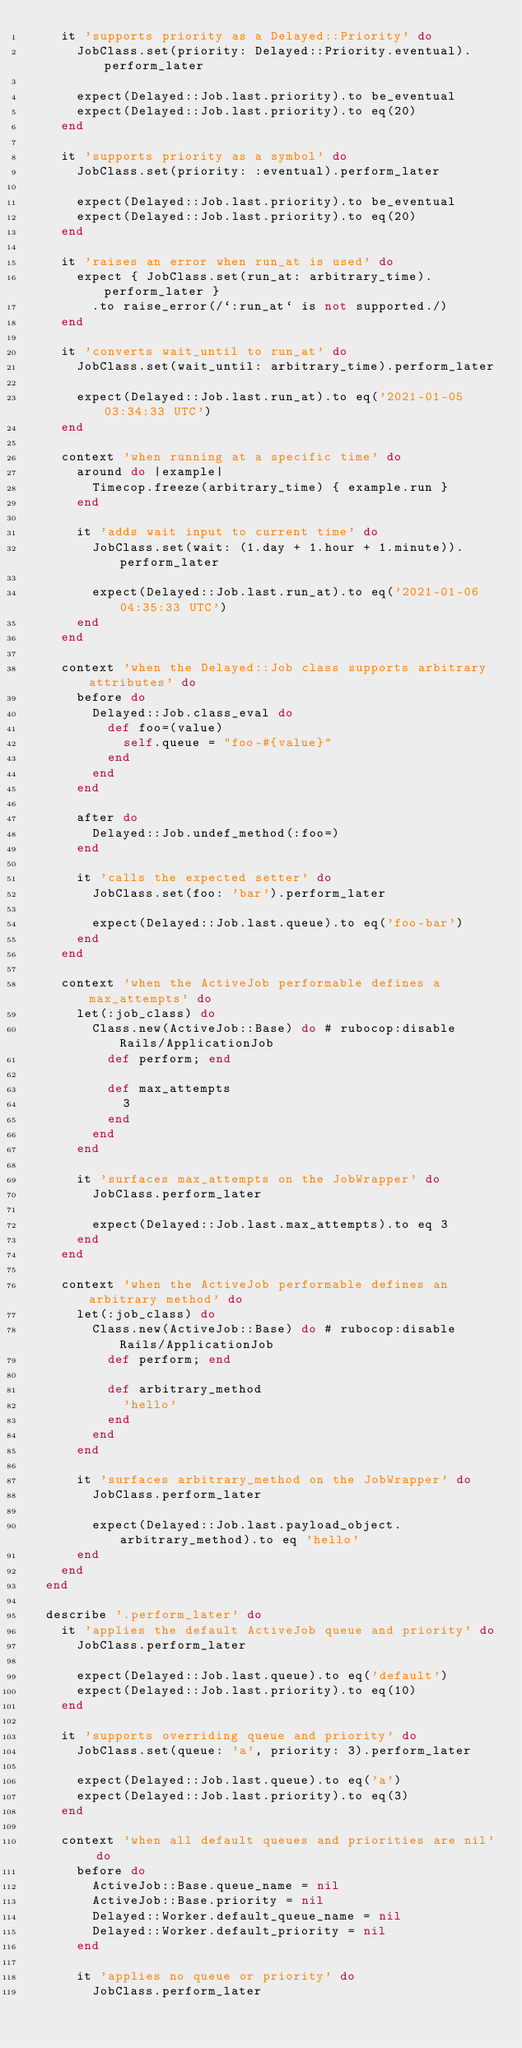<code> <loc_0><loc_0><loc_500><loc_500><_Ruby_>    it 'supports priority as a Delayed::Priority' do
      JobClass.set(priority: Delayed::Priority.eventual).perform_later

      expect(Delayed::Job.last.priority).to be_eventual
      expect(Delayed::Job.last.priority).to eq(20)
    end

    it 'supports priority as a symbol' do
      JobClass.set(priority: :eventual).perform_later

      expect(Delayed::Job.last.priority).to be_eventual
      expect(Delayed::Job.last.priority).to eq(20)
    end

    it 'raises an error when run_at is used' do
      expect { JobClass.set(run_at: arbitrary_time).perform_later }
        .to raise_error(/`:run_at` is not supported./)
    end

    it 'converts wait_until to run_at' do
      JobClass.set(wait_until: arbitrary_time).perform_later

      expect(Delayed::Job.last.run_at).to eq('2021-01-05 03:34:33 UTC')
    end

    context 'when running at a specific time' do
      around do |example|
        Timecop.freeze(arbitrary_time) { example.run }
      end

      it 'adds wait input to current time' do
        JobClass.set(wait: (1.day + 1.hour + 1.minute)).perform_later

        expect(Delayed::Job.last.run_at).to eq('2021-01-06 04:35:33 UTC')
      end
    end

    context 'when the Delayed::Job class supports arbitrary attributes' do
      before do
        Delayed::Job.class_eval do
          def foo=(value)
            self.queue = "foo-#{value}"
          end
        end
      end

      after do
        Delayed::Job.undef_method(:foo=)
      end

      it 'calls the expected setter' do
        JobClass.set(foo: 'bar').perform_later

        expect(Delayed::Job.last.queue).to eq('foo-bar')
      end
    end

    context 'when the ActiveJob performable defines a max_attempts' do
      let(:job_class) do
        Class.new(ActiveJob::Base) do # rubocop:disable Rails/ApplicationJob
          def perform; end

          def max_attempts
            3
          end
        end
      end

      it 'surfaces max_attempts on the JobWrapper' do
        JobClass.perform_later

        expect(Delayed::Job.last.max_attempts).to eq 3
      end
    end

    context 'when the ActiveJob performable defines an arbitrary method' do
      let(:job_class) do
        Class.new(ActiveJob::Base) do # rubocop:disable Rails/ApplicationJob
          def perform; end

          def arbitrary_method
            'hello'
          end
        end
      end

      it 'surfaces arbitrary_method on the JobWrapper' do
        JobClass.perform_later

        expect(Delayed::Job.last.payload_object.arbitrary_method).to eq 'hello'
      end
    end
  end

  describe '.perform_later' do
    it 'applies the default ActiveJob queue and priority' do
      JobClass.perform_later

      expect(Delayed::Job.last.queue).to eq('default')
      expect(Delayed::Job.last.priority).to eq(10)
    end

    it 'supports overriding queue and priority' do
      JobClass.set(queue: 'a', priority: 3).perform_later

      expect(Delayed::Job.last.queue).to eq('a')
      expect(Delayed::Job.last.priority).to eq(3)
    end

    context 'when all default queues and priorities are nil' do
      before do
        ActiveJob::Base.queue_name = nil
        ActiveJob::Base.priority = nil
        Delayed::Worker.default_queue_name = nil
        Delayed::Worker.default_priority = nil
      end

      it 'applies no queue or priority' do
        JobClass.perform_later
</code> 